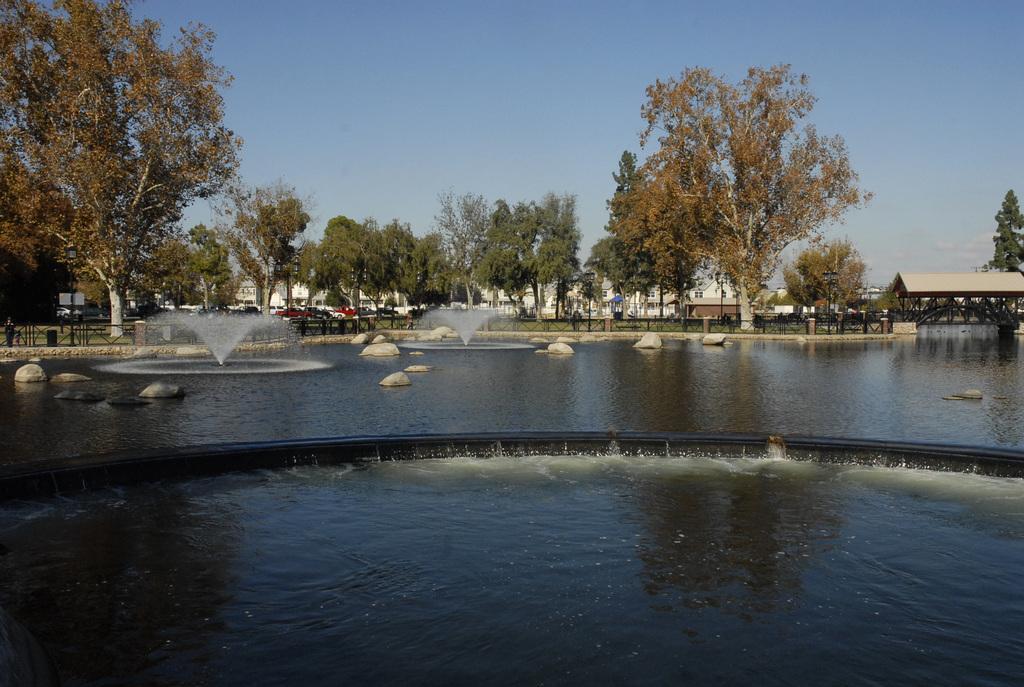Can you describe this image briefly? In this image there is a pond, in that pond there are fountains, stones, in the background there are trees and shed and the sky. 